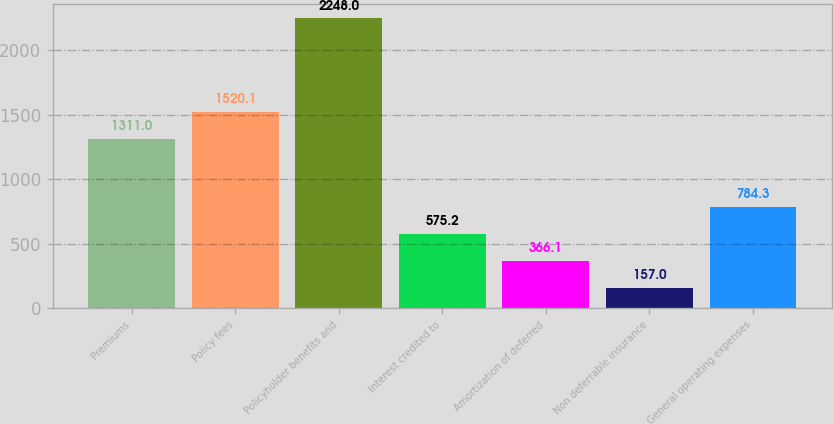<chart> <loc_0><loc_0><loc_500><loc_500><bar_chart><fcel>Premiums<fcel>Policy fees<fcel>Policyholder benefits and<fcel>Interest credited to<fcel>Amortization of deferred<fcel>Non deferrable insurance<fcel>General operating expenses<nl><fcel>1311<fcel>1520.1<fcel>2248<fcel>575.2<fcel>366.1<fcel>157<fcel>784.3<nl></chart> 